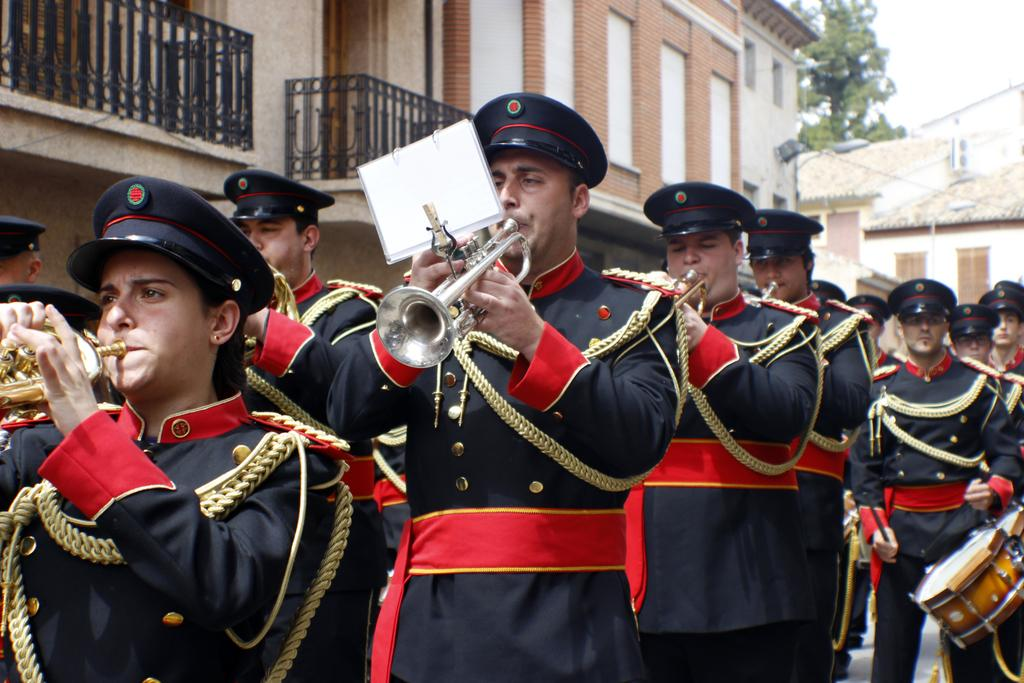How many people are in the group shown in the image? There is a group of people in the image, but the exact number is not specified. What are the people wearing on their heads? The people are wearing caps in the image. What instruments are the people playing in the image? The people are playing drums and trumpets with their hands in the image. What type of structures can be seen in the background of the image? There are buildings visible in the image. What is the paper used for in the image? The purpose of the paper in the image is not specified. What type of vegetation is visible in the background of the image? There are trees in the background of the image. Can you tell me where the kitty is hiding in the image? There is no kitty present in the image. What channel is the group of people tuned into while playing their instruments? The image does not provide any information about a channel or any audio source. 